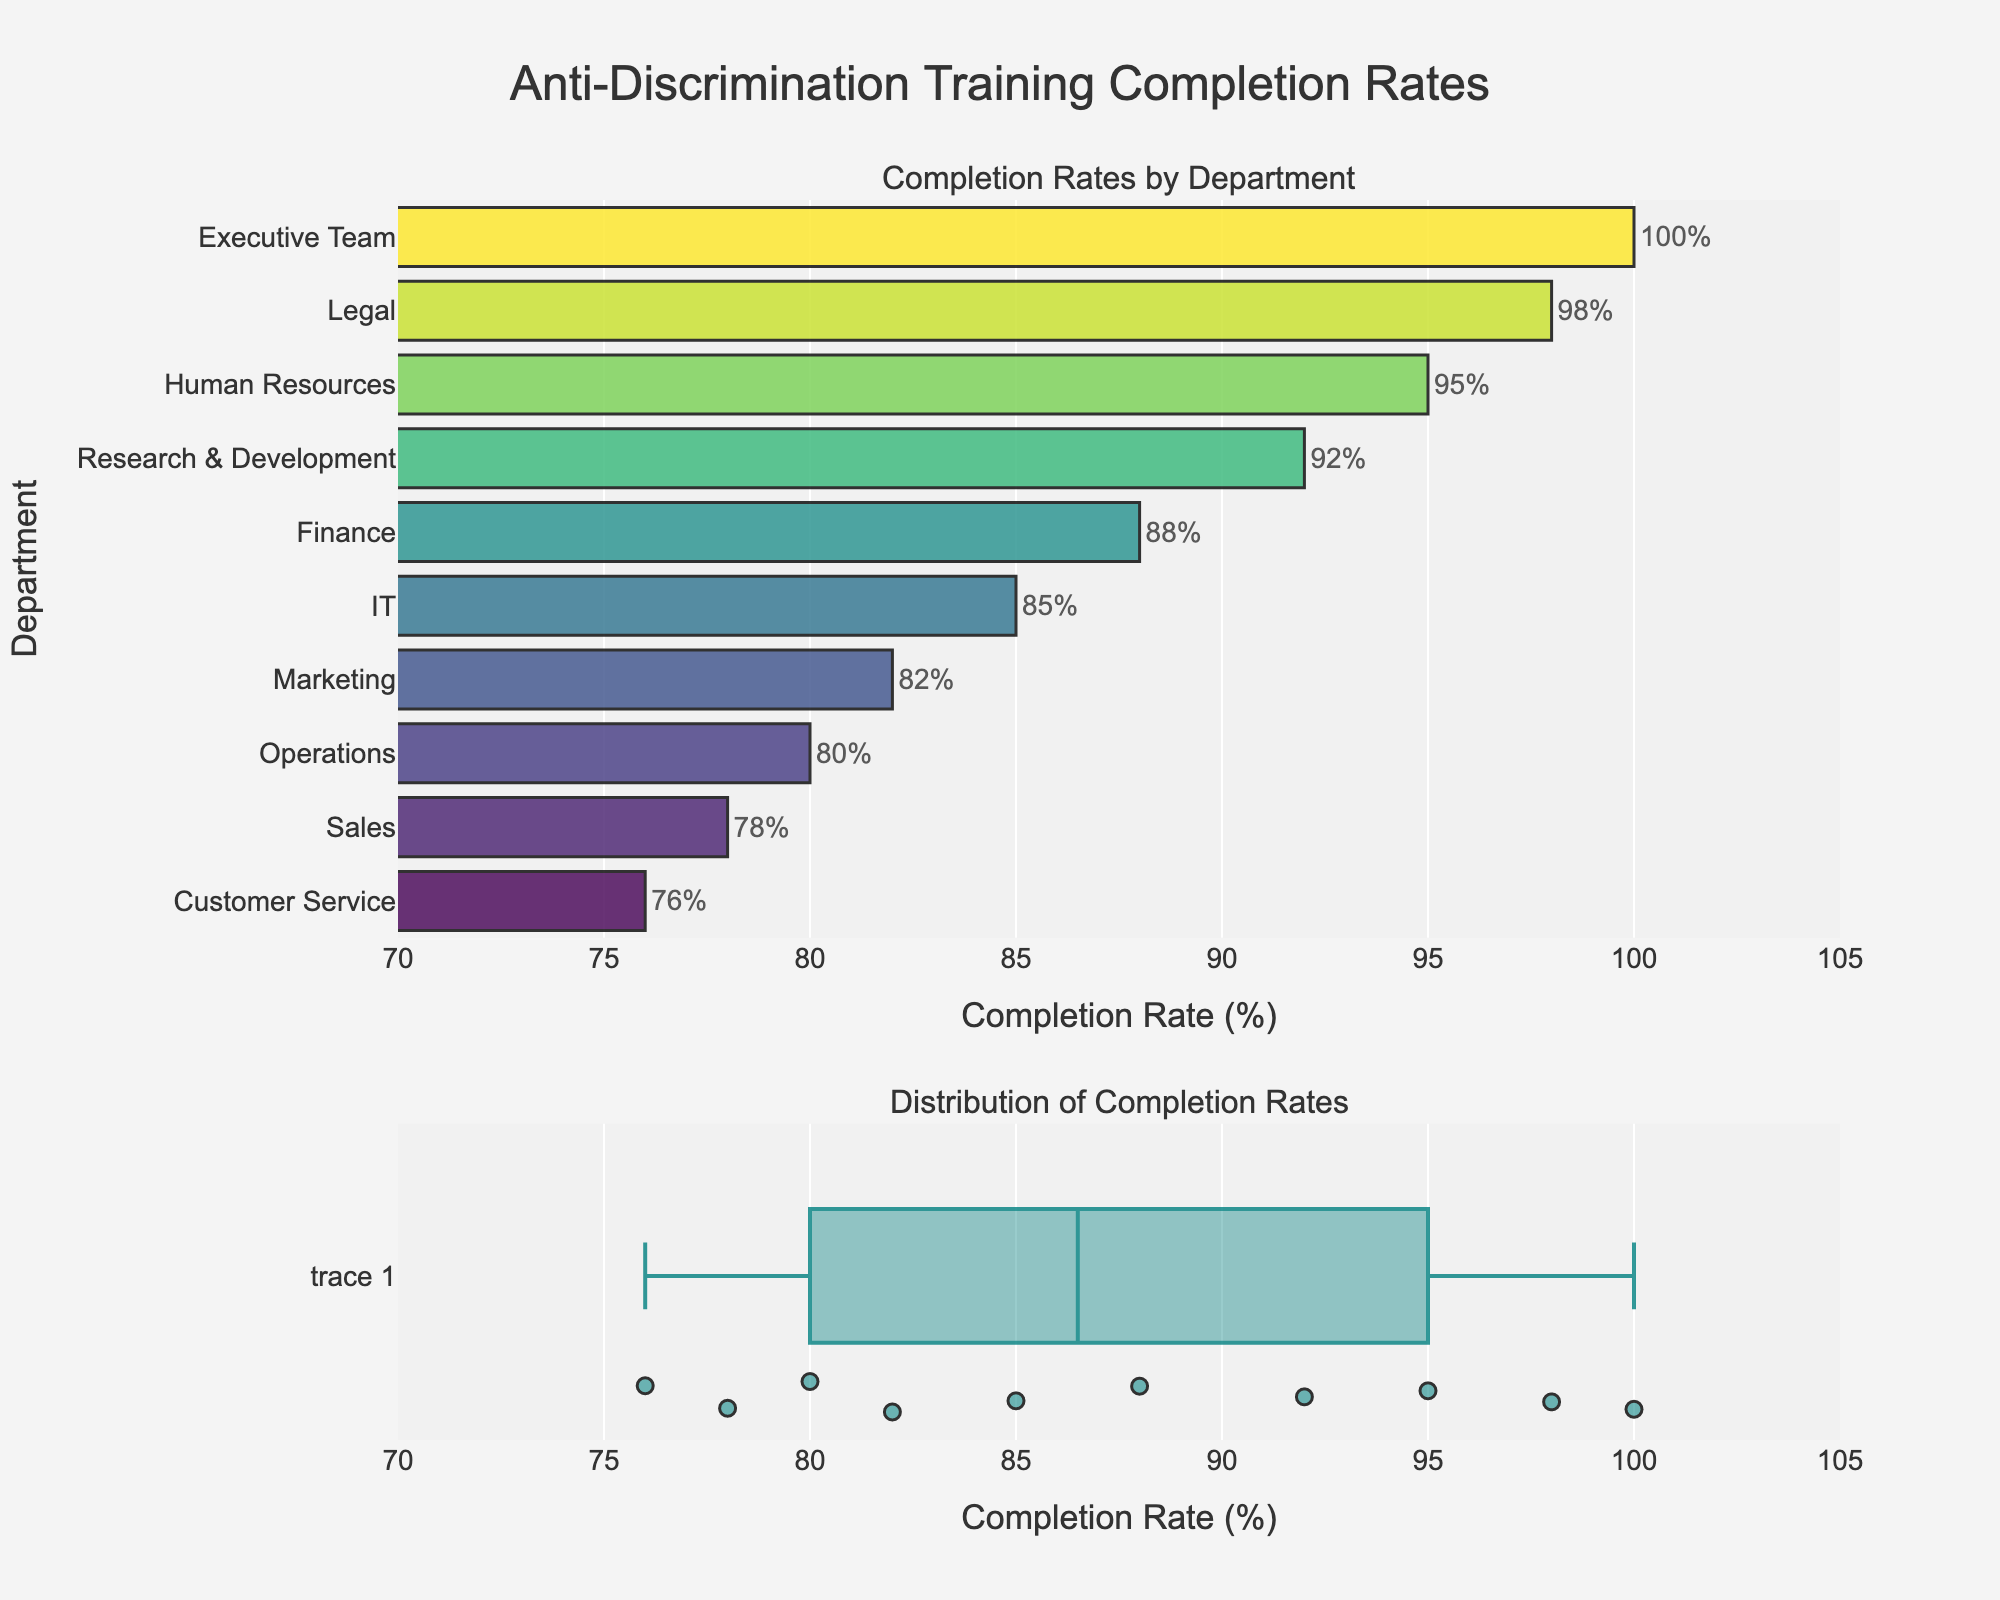What is the title of the figure? The title is located at the top of the figure and reads "Grant Funding Success Rates by Research Focus."
Answer: Grant Funding Success Rates by Research Focus How many research focuses are displayed in the figure? By counting each of the categories listed on the y-axis of the bar chart, there are 10 research focuses displayed.
Answer: 10 Which research focus has the highest success rate? By examining the lengths of the bars and their positions, Cancer Immunology has the highest success rate.
Answer: Cancer Immunology What is the success rate for Neuroimmunology? Locate the bar associated with Neuroimmunology on the y-axis; the text label indicates the success rate as "20%".
Answer: 20% What is the average success rate of all research focuses? Sum up all the success rates (0.28 + 0.32 + 0.25 + 0.35 + 0.30 + 0.22 + 0.20 + 0.27 + 0.23 + 0.26) and divide by the number of focuses (10). The sum is 2.68; thus, the average rate is 2.68/10 = 0.268 or 26.8%.
Answer: 26.8% Which research focuses have success rates above 30%? Identify bars that extend beyond the 30% mark on the x-axis. These are Cancer Immunology (35%), Adaptive Immunity (32%), and Vaccine Development (30%).
Answer: Cancer Immunology, Adaptive Immunity, and Vaccine Development What is the difference in success rate between the highest and lowest research focuses? Subtract the lowest success rate (Neuroimmunology 20%) from the highest success rate (Cancer Immunology 35%). The calculation is 35% - 20% = 15%.
Answer: 15% Which research focus has a success rate closest to the average rate for all categories? Calculate the deviation of each focus from the average (26.8%) and find the closest match. The closest rates are Innate Immunity (28%) and Mucosal Immunology (27%), with Mucosal Immunology being slightly closer.
Answer: Mucosal Immunology What color scale is used in the bar chart? The color scale used for the bars is Viridis, which transitions from dark to light colors as the success rate increases.
Answer: Viridis 